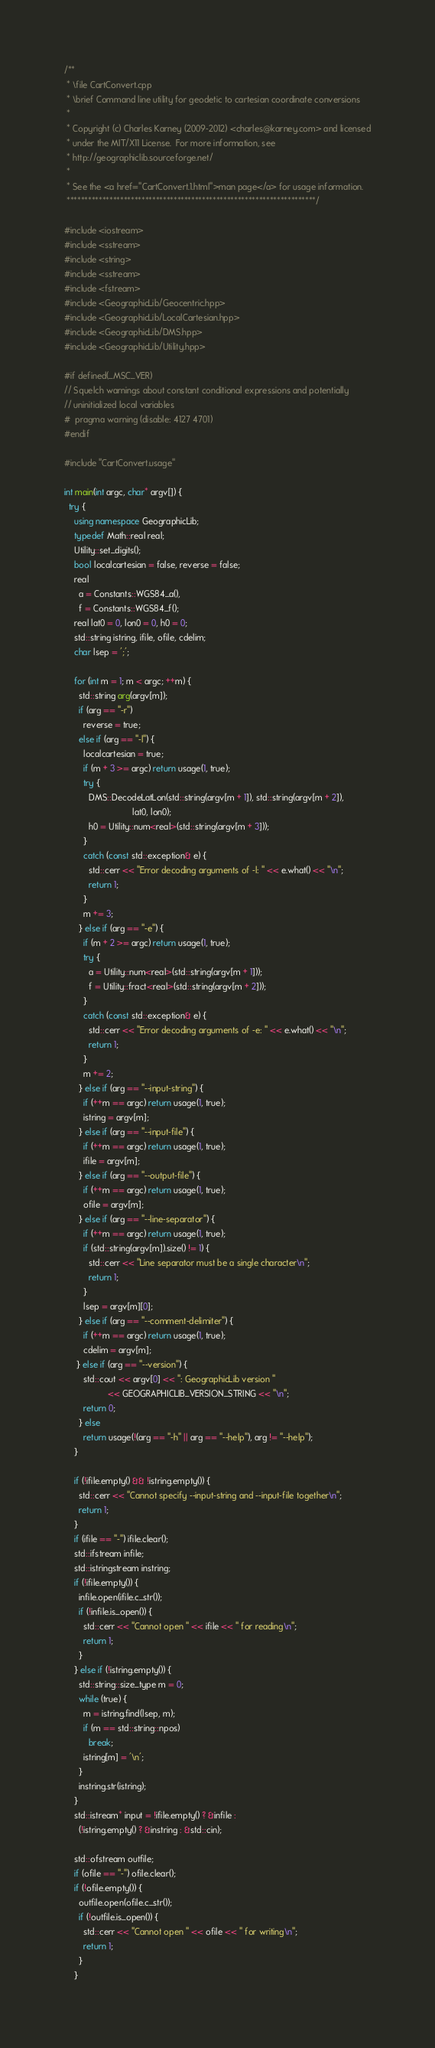Convert code to text. <code><loc_0><loc_0><loc_500><loc_500><_C++_>/**
 * \file CartConvert.cpp
 * \brief Command line utility for geodetic to cartesian coordinate conversions
 *
 * Copyright (c) Charles Karney (2009-2012) <charles@karney.com> and licensed
 * under the MIT/X11 License.  For more information, see
 * http://geographiclib.sourceforge.net/
 *
 * See the <a href="CartConvert.1.html">man page</a> for usage information.
 **********************************************************************/

#include <iostream>
#include <sstream>
#include <string>
#include <sstream>
#include <fstream>
#include <GeographicLib/Geocentric.hpp>
#include <GeographicLib/LocalCartesian.hpp>
#include <GeographicLib/DMS.hpp>
#include <GeographicLib/Utility.hpp>

#if defined(_MSC_VER)
// Squelch warnings about constant conditional expressions and potentially
// uninitialized local variables
#  pragma warning (disable: 4127 4701)
#endif

#include "CartConvert.usage"

int main(int argc, char* argv[]) {
  try {
    using namespace GeographicLib;
    typedef Math::real real;
    Utility::set_digits();
    bool localcartesian = false, reverse = false;
    real
      a = Constants::WGS84_a(),
      f = Constants::WGS84_f();
    real lat0 = 0, lon0 = 0, h0 = 0;
    std::string istring, ifile, ofile, cdelim;
    char lsep = ';';

    for (int m = 1; m < argc; ++m) {
      std::string arg(argv[m]);
      if (arg == "-r")
        reverse = true;
      else if (arg == "-l") {
        localcartesian = true;
        if (m + 3 >= argc) return usage(1, true);
        try {
          DMS::DecodeLatLon(std::string(argv[m + 1]), std::string(argv[m + 2]),
                            lat0, lon0);
          h0 = Utility::num<real>(std::string(argv[m + 3]));
        }
        catch (const std::exception& e) {
          std::cerr << "Error decoding arguments of -l: " << e.what() << "\n";
          return 1;
        }
        m += 3;
      } else if (arg == "-e") {
        if (m + 2 >= argc) return usage(1, true);
        try {
          a = Utility::num<real>(std::string(argv[m + 1]));
          f = Utility::fract<real>(std::string(argv[m + 2]));
        }
        catch (const std::exception& e) {
          std::cerr << "Error decoding arguments of -e: " << e.what() << "\n";
          return 1;
        }
        m += 2;
      } else if (arg == "--input-string") {
        if (++m == argc) return usage(1, true);
        istring = argv[m];
      } else if (arg == "--input-file") {
        if (++m == argc) return usage(1, true);
        ifile = argv[m];
      } else if (arg == "--output-file") {
        if (++m == argc) return usage(1, true);
        ofile = argv[m];
      } else if (arg == "--line-separator") {
        if (++m == argc) return usage(1, true);
        if (std::string(argv[m]).size() != 1) {
          std::cerr << "Line separator must be a single character\n";
          return 1;
        }
        lsep = argv[m][0];
      } else if (arg == "--comment-delimiter") {
        if (++m == argc) return usage(1, true);
        cdelim = argv[m];
     } else if (arg == "--version") {
        std::cout << argv[0] << ": GeographicLib version "
                  << GEOGRAPHICLIB_VERSION_STRING << "\n";
        return 0;
      } else
        return usage(!(arg == "-h" || arg == "--help"), arg != "--help");
    }

    if (!ifile.empty() && !istring.empty()) {
      std::cerr << "Cannot specify --input-string and --input-file together\n";
      return 1;
    }
    if (ifile == "-") ifile.clear();
    std::ifstream infile;
    std::istringstream instring;
    if (!ifile.empty()) {
      infile.open(ifile.c_str());
      if (!infile.is_open()) {
        std::cerr << "Cannot open " << ifile << " for reading\n";
        return 1;
      }
    } else if (!istring.empty()) {
      std::string::size_type m = 0;
      while (true) {
        m = istring.find(lsep, m);
        if (m == std::string::npos)
          break;
        istring[m] = '\n';
      }
      instring.str(istring);
    }
    std::istream* input = !ifile.empty() ? &infile :
      (!istring.empty() ? &instring : &std::cin);

    std::ofstream outfile;
    if (ofile == "-") ofile.clear();
    if (!ofile.empty()) {
      outfile.open(ofile.c_str());
      if (!outfile.is_open()) {
        std::cerr << "Cannot open " << ofile << " for writing\n";
        return 1;
      }
    }</code> 